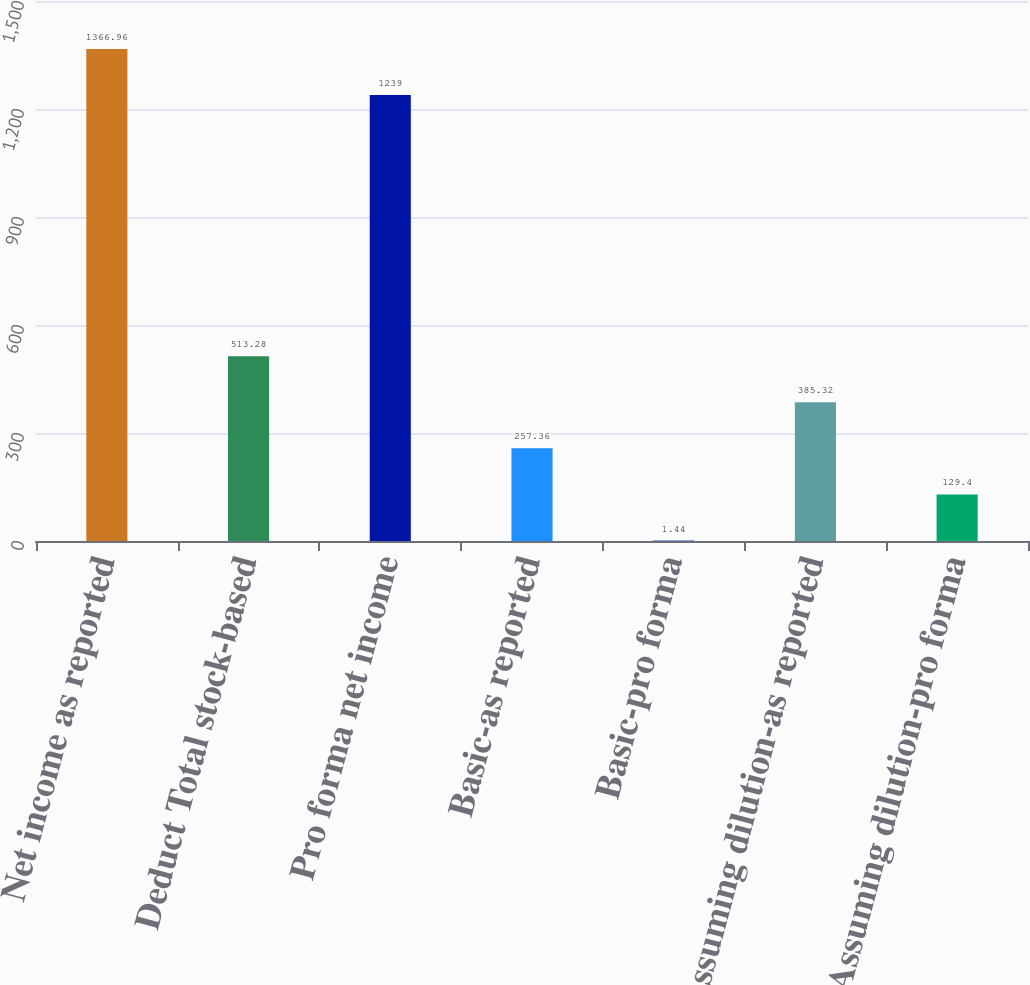<chart> <loc_0><loc_0><loc_500><loc_500><bar_chart><fcel>Net income as reported<fcel>Deduct Total stock-based<fcel>Pro forma net income<fcel>Basic-as reported<fcel>Basic-pro forma<fcel>Assuming dilution-as reported<fcel>Assuming dilution-pro forma<nl><fcel>1366.96<fcel>513.28<fcel>1239<fcel>257.36<fcel>1.44<fcel>385.32<fcel>129.4<nl></chart> 